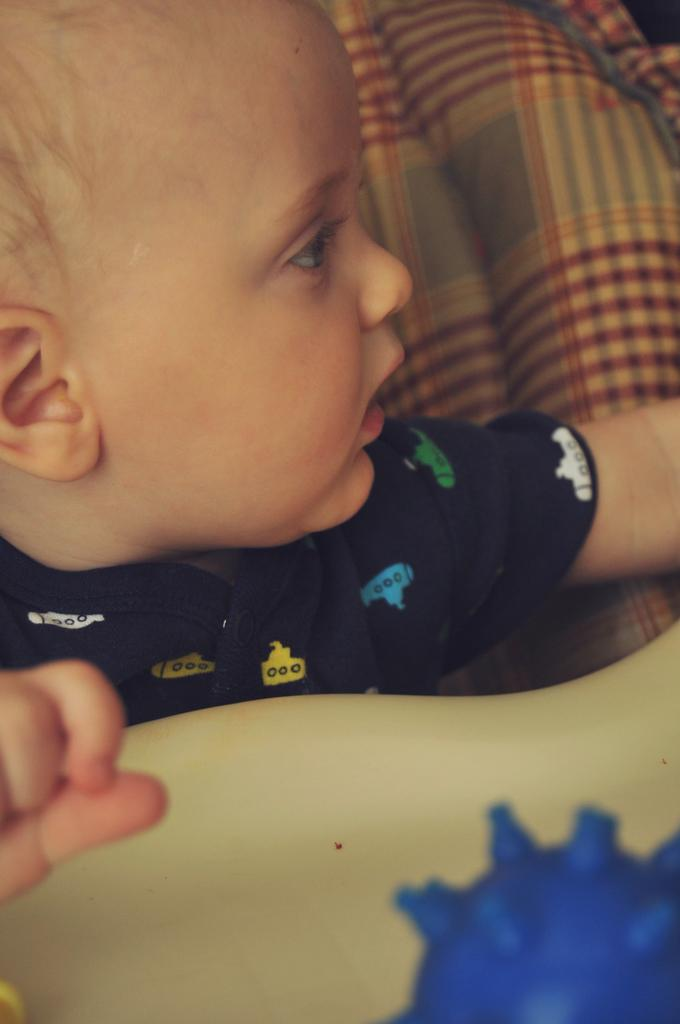What is the main subject of the picture? The main subject of the picture is a baby. Can you describe the background or setting of the image? There is some cloth behind the baby. What type of haircut does the baby have in the image? There is no indication of the baby's haircut in the image, as the focus is on the baby and the cloth behind it. 